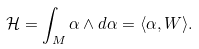Convert formula to latex. <formula><loc_0><loc_0><loc_500><loc_500>\mathcal { H } = \int _ { M } \alpha \wedge d \alpha = \langle \alpha , W \rangle .</formula> 